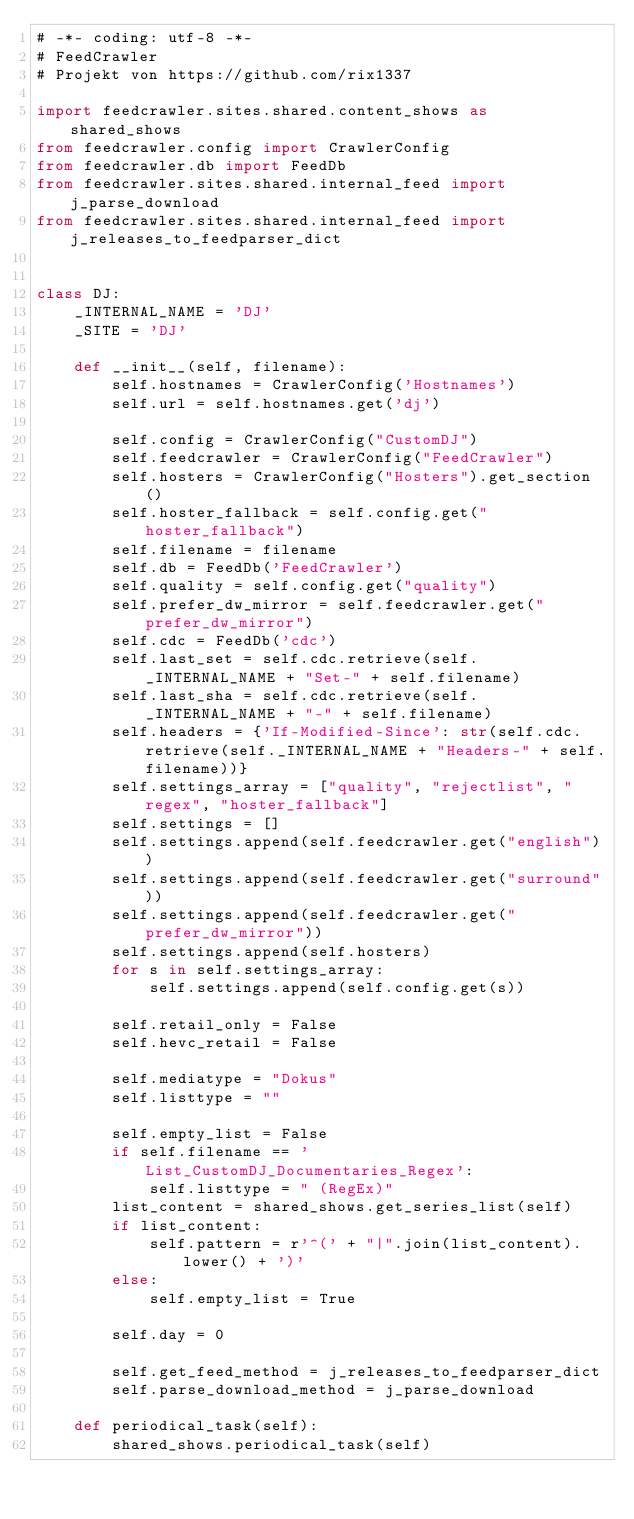<code> <loc_0><loc_0><loc_500><loc_500><_Python_># -*- coding: utf-8 -*-
# FeedCrawler
# Projekt von https://github.com/rix1337

import feedcrawler.sites.shared.content_shows as shared_shows
from feedcrawler.config import CrawlerConfig
from feedcrawler.db import FeedDb
from feedcrawler.sites.shared.internal_feed import j_parse_download
from feedcrawler.sites.shared.internal_feed import j_releases_to_feedparser_dict


class DJ:
    _INTERNAL_NAME = 'DJ'
    _SITE = 'DJ'

    def __init__(self, filename):
        self.hostnames = CrawlerConfig('Hostnames')
        self.url = self.hostnames.get('dj')

        self.config = CrawlerConfig("CustomDJ")
        self.feedcrawler = CrawlerConfig("FeedCrawler")
        self.hosters = CrawlerConfig("Hosters").get_section()
        self.hoster_fallback = self.config.get("hoster_fallback")
        self.filename = filename
        self.db = FeedDb('FeedCrawler')
        self.quality = self.config.get("quality")
        self.prefer_dw_mirror = self.feedcrawler.get("prefer_dw_mirror")
        self.cdc = FeedDb('cdc')
        self.last_set = self.cdc.retrieve(self._INTERNAL_NAME + "Set-" + self.filename)
        self.last_sha = self.cdc.retrieve(self._INTERNAL_NAME + "-" + self.filename)
        self.headers = {'If-Modified-Since': str(self.cdc.retrieve(self._INTERNAL_NAME + "Headers-" + self.filename))}
        self.settings_array = ["quality", "rejectlist", "regex", "hoster_fallback"]
        self.settings = []
        self.settings.append(self.feedcrawler.get("english"))
        self.settings.append(self.feedcrawler.get("surround"))
        self.settings.append(self.feedcrawler.get("prefer_dw_mirror"))
        self.settings.append(self.hosters)
        for s in self.settings_array:
            self.settings.append(self.config.get(s))

        self.retail_only = False
        self.hevc_retail = False

        self.mediatype = "Dokus"
        self.listtype = ""

        self.empty_list = False
        if self.filename == 'List_CustomDJ_Documentaries_Regex':
            self.listtype = " (RegEx)"
        list_content = shared_shows.get_series_list(self)
        if list_content:
            self.pattern = r'^(' + "|".join(list_content).lower() + ')'
        else:
            self.empty_list = True

        self.day = 0

        self.get_feed_method = j_releases_to_feedparser_dict
        self.parse_download_method = j_parse_download

    def periodical_task(self):
        shared_shows.periodical_task(self)
</code> 